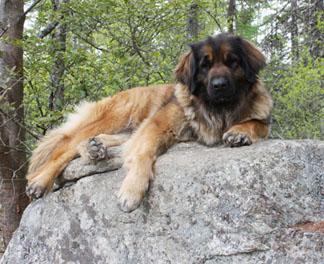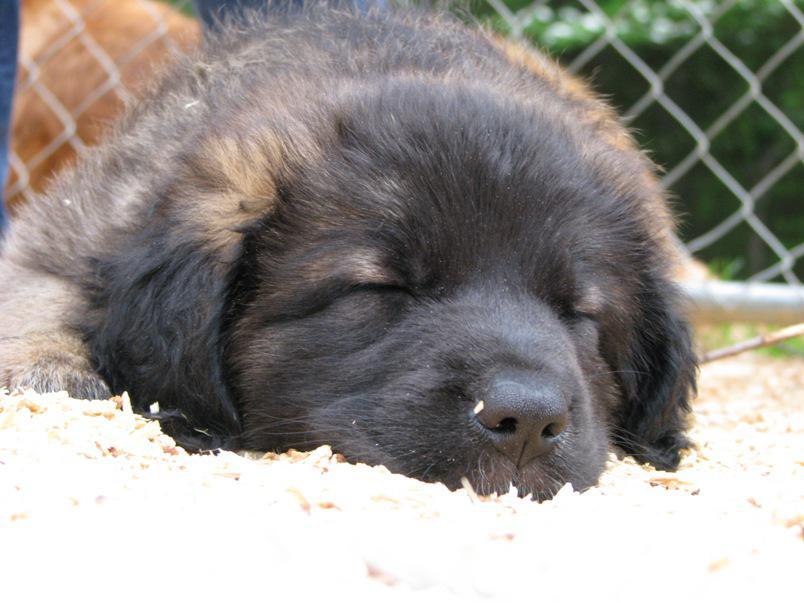The first image is the image on the left, the second image is the image on the right. Assess this claim about the two images: "All the dogs are asleep.". Correct or not? Answer yes or no. No. The first image is the image on the left, the second image is the image on the right. For the images shown, is this caption "The dog in the left image is awake and alert." true? Answer yes or no. Yes. 